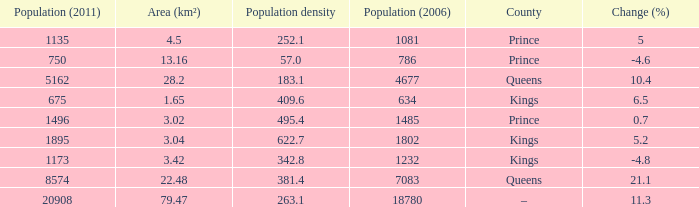What was the Area (km²) when the Population (2011) was 8574, and the Population density was larger than 381.4? None. 